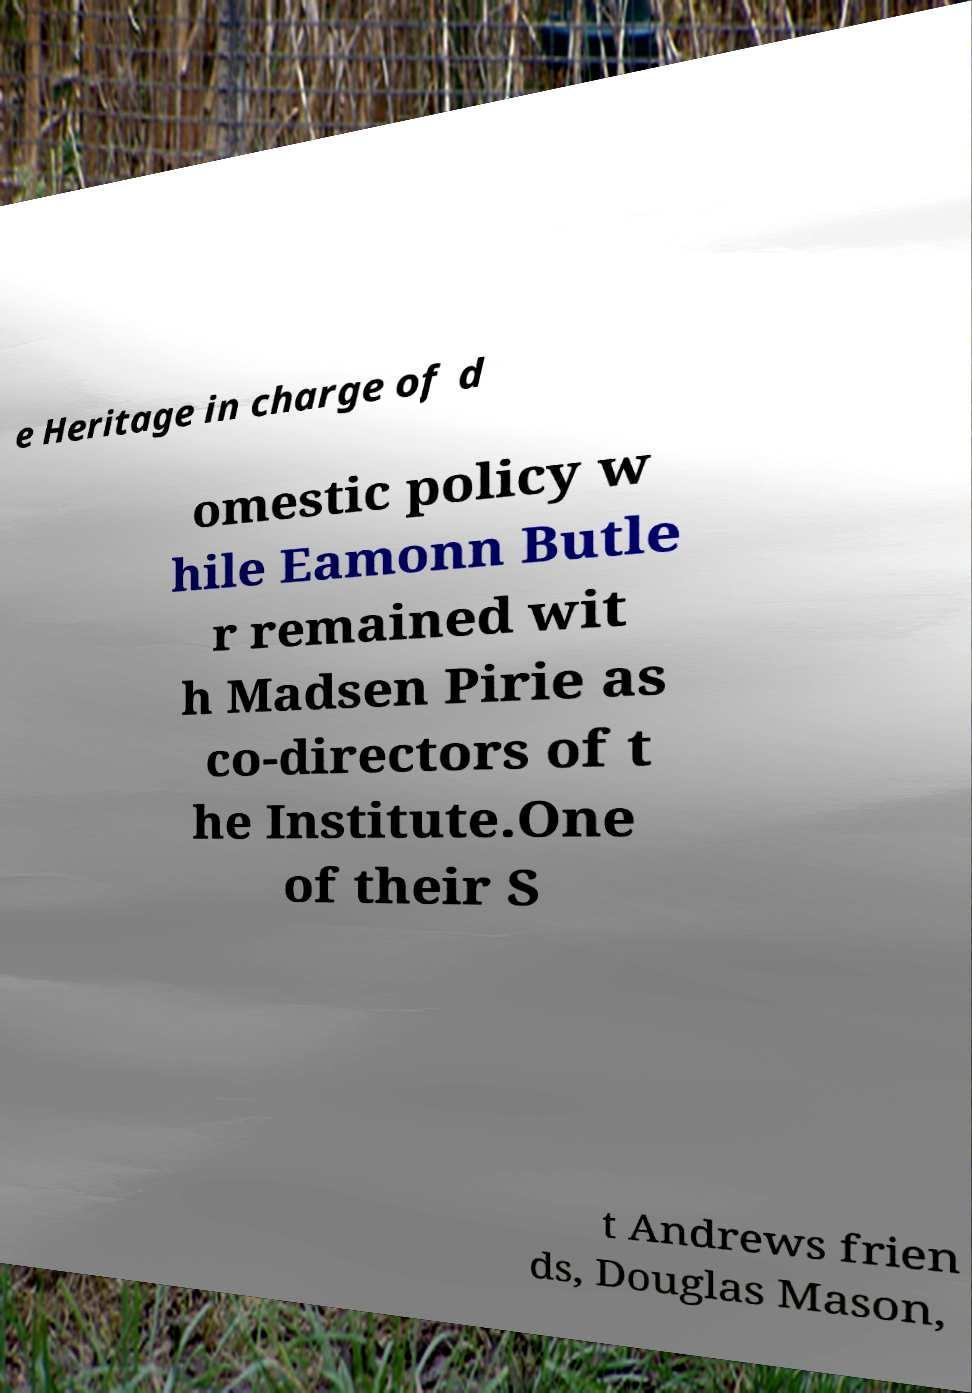What messages or text are displayed in this image? I need them in a readable, typed format. e Heritage in charge of d omestic policy w hile Eamonn Butle r remained wit h Madsen Pirie as co-directors of t he Institute.One of their S t Andrews frien ds, Douglas Mason, 